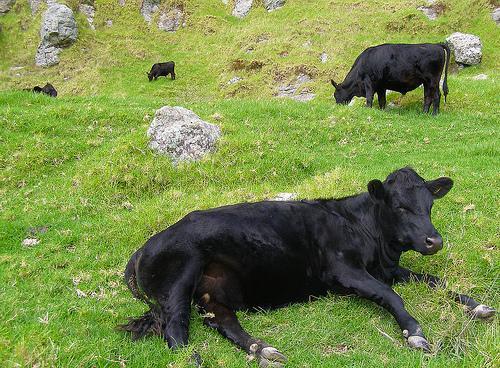How many cows are there?
Give a very brief answer. 4. 